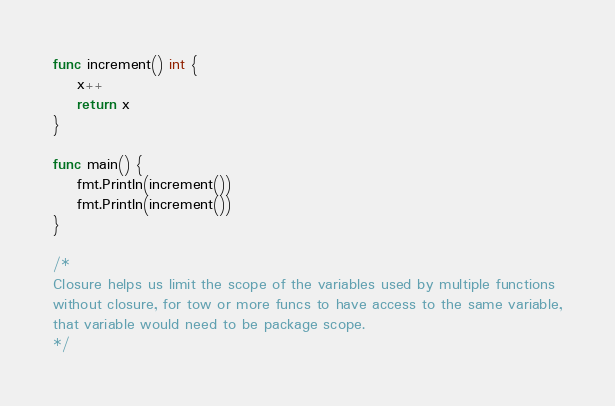<code> <loc_0><loc_0><loc_500><loc_500><_Go_>func increment() int {
	x++
	return x
}

func main() {
	fmt.Println(increment())
	fmt.Println(increment())
}

/*
Closure helps us limit the scope of the variables used by multiple functions
without closure, for tow or more funcs to have access to the same variable,
that variable would need to be package scope.
*/
</code> 